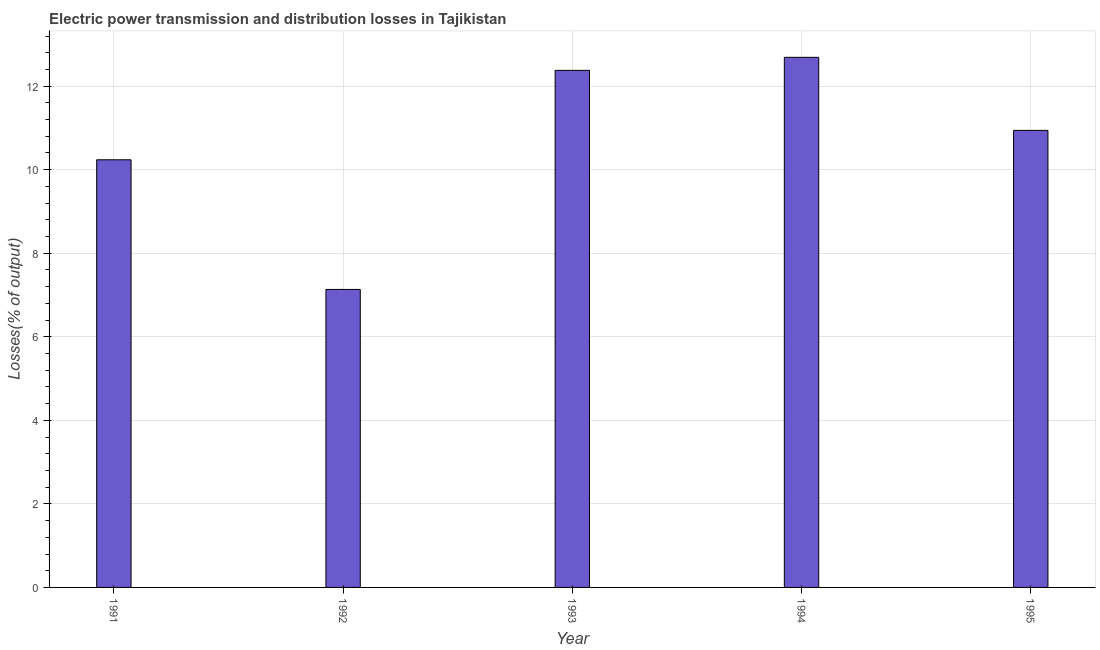What is the title of the graph?
Your answer should be very brief. Electric power transmission and distribution losses in Tajikistan. What is the label or title of the X-axis?
Provide a succinct answer. Year. What is the label or title of the Y-axis?
Provide a short and direct response. Losses(% of output). What is the electric power transmission and distribution losses in 1993?
Provide a short and direct response. 12.38. Across all years, what is the maximum electric power transmission and distribution losses?
Make the answer very short. 12.69. Across all years, what is the minimum electric power transmission and distribution losses?
Offer a terse response. 7.13. In which year was the electric power transmission and distribution losses minimum?
Provide a short and direct response. 1992. What is the sum of the electric power transmission and distribution losses?
Provide a succinct answer. 53.38. What is the difference between the electric power transmission and distribution losses in 1991 and 1995?
Offer a very short reply. -0.7. What is the average electric power transmission and distribution losses per year?
Your answer should be compact. 10.68. What is the median electric power transmission and distribution losses?
Your response must be concise. 10.94. What is the ratio of the electric power transmission and distribution losses in 1991 to that in 1993?
Offer a very short reply. 0.83. Is the electric power transmission and distribution losses in 1992 less than that in 1993?
Offer a terse response. Yes. Is the difference between the electric power transmission and distribution losses in 1991 and 1995 greater than the difference between any two years?
Your answer should be compact. No. What is the difference between the highest and the second highest electric power transmission and distribution losses?
Offer a very short reply. 0.31. What is the difference between the highest and the lowest electric power transmission and distribution losses?
Your answer should be compact. 5.56. In how many years, is the electric power transmission and distribution losses greater than the average electric power transmission and distribution losses taken over all years?
Ensure brevity in your answer.  3. How many bars are there?
Your response must be concise. 5. Are all the bars in the graph horizontal?
Provide a short and direct response. No. What is the difference between two consecutive major ticks on the Y-axis?
Provide a short and direct response. 2. Are the values on the major ticks of Y-axis written in scientific E-notation?
Make the answer very short. No. What is the Losses(% of output) of 1991?
Offer a terse response. 10.24. What is the Losses(% of output) in 1992?
Provide a short and direct response. 7.13. What is the Losses(% of output) of 1993?
Give a very brief answer. 12.38. What is the Losses(% of output) of 1994?
Your response must be concise. 12.69. What is the Losses(% of output) in 1995?
Ensure brevity in your answer.  10.94. What is the difference between the Losses(% of output) in 1991 and 1992?
Your answer should be compact. 3.1. What is the difference between the Losses(% of output) in 1991 and 1993?
Your answer should be compact. -2.14. What is the difference between the Losses(% of output) in 1991 and 1994?
Offer a terse response. -2.45. What is the difference between the Losses(% of output) in 1991 and 1995?
Your response must be concise. -0.7. What is the difference between the Losses(% of output) in 1992 and 1993?
Your response must be concise. -5.24. What is the difference between the Losses(% of output) in 1992 and 1994?
Provide a short and direct response. -5.56. What is the difference between the Losses(% of output) in 1992 and 1995?
Give a very brief answer. -3.81. What is the difference between the Losses(% of output) in 1993 and 1994?
Make the answer very short. -0.31. What is the difference between the Losses(% of output) in 1993 and 1995?
Give a very brief answer. 1.44. What is the difference between the Losses(% of output) in 1994 and 1995?
Keep it short and to the point. 1.75. What is the ratio of the Losses(% of output) in 1991 to that in 1992?
Offer a terse response. 1.44. What is the ratio of the Losses(% of output) in 1991 to that in 1993?
Your answer should be compact. 0.83. What is the ratio of the Losses(% of output) in 1991 to that in 1994?
Your answer should be compact. 0.81. What is the ratio of the Losses(% of output) in 1991 to that in 1995?
Make the answer very short. 0.94. What is the ratio of the Losses(% of output) in 1992 to that in 1993?
Provide a succinct answer. 0.58. What is the ratio of the Losses(% of output) in 1992 to that in 1994?
Give a very brief answer. 0.56. What is the ratio of the Losses(% of output) in 1992 to that in 1995?
Provide a succinct answer. 0.65. What is the ratio of the Losses(% of output) in 1993 to that in 1994?
Provide a short and direct response. 0.97. What is the ratio of the Losses(% of output) in 1993 to that in 1995?
Offer a terse response. 1.13. What is the ratio of the Losses(% of output) in 1994 to that in 1995?
Provide a short and direct response. 1.16. 